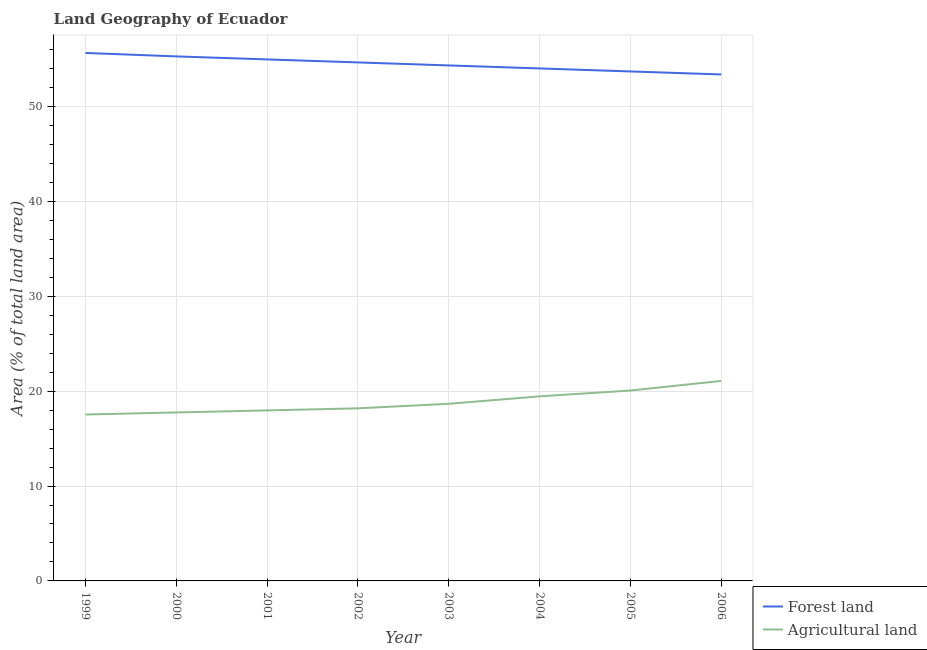Does the line corresponding to percentage of land area under forests intersect with the line corresponding to percentage of land area under agriculture?
Provide a short and direct response. No. Is the number of lines equal to the number of legend labels?
Provide a succinct answer. Yes. What is the percentage of land area under agriculture in 2004?
Ensure brevity in your answer.  19.45. Across all years, what is the maximum percentage of land area under forests?
Your answer should be very brief. 55.64. Across all years, what is the minimum percentage of land area under agriculture?
Provide a short and direct response. 17.54. What is the total percentage of land area under agriculture in the graph?
Provide a short and direct response. 150.71. What is the difference between the percentage of land area under forests in 2000 and that in 2005?
Offer a terse response. 1.59. What is the difference between the percentage of land area under forests in 1999 and the percentage of land area under agriculture in 2006?
Your response must be concise. 34.56. What is the average percentage of land area under forests per year?
Provide a succinct answer. 54.49. In the year 2001, what is the difference between the percentage of land area under agriculture and percentage of land area under forests?
Give a very brief answer. -36.99. In how many years, is the percentage of land area under agriculture greater than 22 %?
Ensure brevity in your answer.  0. What is the ratio of the percentage of land area under forests in 1999 to that in 2001?
Offer a terse response. 1.01. Is the percentage of land area under forests in 2004 less than that in 2006?
Make the answer very short. No. Is the difference between the percentage of land area under forests in 2000 and 2004 greater than the difference between the percentage of land area under agriculture in 2000 and 2004?
Make the answer very short. Yes. What is the difference between the highest and the second highest percentage of land area under agriculture?
Ensure brevity in your answer.  1.01. What is the difference between the highest and the lowest percentage of land area under forests?
Keep it short and to the point. 2.27. In how many years, is the percentage of land area under agriculture greater than the average percentage of land area under agriculture taken over all years?
Give a very brief answer. 3. Is the percentage of land area under forests strictly greater than the percentage of land area under agriculture over the years?
Offer a terse response. Yes. Is the percentage of land area under forests strictly less than the percentage of land area under agriculture over the years?
Provide a succinct answer. No. How many years are there in the graph?
Ensure brevity in your answer.  8. What is the difference between two consecutive major ticks on the Y-axis?
Offer a very short reply. 10. How many legend labels are there?
Make the answer very short. 2. What is the title of the graph?
Offer a very short reply. Land Geography of Ecuador. Does "By country of asylum" appear as one of the legend labels in the graph?
Offer a terse response. No. What is the label or title of the Y-axis?
Give a very brief answer. Area (% of total land area). What is the Area (% of total land area) of Forest land in 1999?
Your answer should be compact. 55.64. What is the Area (% of total land area) of Agricultural land in 1999?
Make the answer very short. 17.54. What is the Area (% of total land area) of Forest land in 2000?
Provide a succinct answer. 55.28. What is the Area (% of total land area) in Agricultural land in 2000?
Offer a very short reply. 17.75. What is the Area (% of total land area) in Forest land in 2001?
Ensure brevity in your answer.  54.96. What is the Area (% of total land area) of Agricultural land in 2001?
Offer a very short reply. 17.97. What is the Area (% of total land area) of Forest land in 2002?
Your answer should be compact. 54.64. What is the Area (% of total land area) of Agricultural land in 2002?
Your answer should be very brief. 18.19. What is the Area (% of total land area) in Forest land in 2003?
Offer a very short reply. 54.33. What is the Area (% of total land area) in Agricultural land in 2003?
Make the answer very short. 18.67. What is the Area (% of total land area) in Forest land in 2004?
Offer a terse response. 54.01. What is the Area (% of total land area) in Agricultural land in 2004?
Make the answer very short. 19.45. What is the Area (% of total land area) of Forest land in 2005?
Give a very brief answer. 53.69. What is the Area (% of total land area) of Agricultural land in 2005?
Ensure brevity in your answer.  20.07. What is the Area (% of total land area) of Forest land in 2006?
Give a very brief answer. 53.38. What is the Area (% of total land area) of Agricultural land in 2006?
Give a very brief answer. 21.08. Across all years, what is the maximum Area (% of total land area) of Forest land?
Your answer should be very brief. 55.64. Across all years, what is the maximum Area (% of total land area) in Agricultural land?
Provide a short and direct response. 21.08. Across all years, what is the minimum Area (% of total land area) of Forest land?
Provide a short and direct response. 53.38. Across all years, what is the minimum Area (% of total land area) in Agricultural land?
Offer a terse response. 17.54. What is the total Area (% of total land area) of Forest land in the graph?
Offer a terse response. 435.93. What is the total Area (% of total land area) in Agricultural land in the graph?
Your answer should be compact. 150.71. What is the difference between the Area (% of total land area) in Forest land in 1999 and that in 2000?
Your response must be concise. 0.36. What is the difference between the Area (% of total land area) in Agricultural land in 1999 and that in 2000?
Make the answer very short. -0.22. What is the difference between the Area (% of total land area) of Forest land in 1999 and that in 2001?
Make the answer very short. 0.68. What is the difference between the Area (% of total land area) in Agricultural land in 1999 and that in 2001?
Your answer should be compact. -0.43. What is the difference between the Area (% of total land area) in Agricultural land in 1999 and that in 2002?
Your answer should be very brief. -0.65. What is the difference between the Area (% of total land area) in Forest land in 1999 and that in 2003?
Provide a short and direct response. 1.31. What is the difference between the Area (% of total land area) in Agricultural land in 1999 and that in 2003?
Your answer should be compact. -1.13. What is the difference between the Area (% of total land area) of Forest land in 1999 and that in 2004?
Offer a very short reply. 1.63. What is the difference between the Area (% of total land area) in Agricultural land in 1999 and that in 2004?
Give a very brief answer. -1.91. What is the difference between the Area (% of total land area) in Forest land in 1999 and that in 2005?
Provide a short and direct response. 1.95. What is the difference between the Area (% of total land area) of Agricultural land in 1999 and that in 2005?
Offer a terse response. -2.53. What is the difference between the Area (% of total land area) in Forest land in 1999 and that in 2006?
Keep it short and to the point. 2.27. What is the difference between the Area (% of total land area) in Agricultural land in 1999 and that in 2006?
Ensure brevity in your answer.  -3.54. What is the difference between the Area (% of total land area) in Forest land in 2000 and that in 2001?
Provide a succinct answer. 0.32. What is the difference between the Area (% of total land area) of Agricultural land in 2000 and that in 2001?
Provide a short and direct response. -0.22. What is the difference between the Area (% of total land area) of Forest land in 2000 and that in 2002?
Provide a short and direct response. 0.63. What is the difference between the Area (% of total land area) of Agricultural land in 2000 and that in 2002?
Your answer should be very brief. -0.43. What is the difference between the Area (% of total land area) in Forest land in 2000 and that in 2003?
Provide a succinct answer. 0.95. What is the difference between the Area (% of total land area) of Agricultural land in 2000 and that in 2003?
Offer a terse response. -0.91. What is the difference between the Area (% of total land area) of Forest land in 2000 and that in 2004?
Give a very brief answer. 1.27. What is the difference between the Area (% of total land area) of Agricultural land in 2000 and that in 2004?
Your response must be concise. -1.7. What is the difference between the Area (% of total land area) in Forest land in 2000 and that in 2005?
Provide a succinct answer. 1.59. What is the difference between the Area (% of total land area) of Agricultural land in 2000 and that in 2005?
Your response must be concise. -2.31. What is the difference between the Area (% of total land area) in Forest land in 2000 and that in 2006?
Your response must be concise. 1.9. What is the difference between the Area (% of total land area) of Agricultural land in 2000 and that in 2006?
Offer a terse response. -3.32. What is the difference between the Area (% of total land area) in Forest land in 2001 and that in 2002?
Offer a terse response. 0.32. What is the difference between the Area (% of total land area) in Agricultural land in 2001 and that in 2002?
Provide a succinct answer. -0.22. What is the difference between the Area (% of total land area) in Forest land in 2001 and that in 2003?
Your response must be concise. 0.63. What is the difference between the Area (% of total land area) of Agricultural land in 2001 and that in 2003?
Provide a short and direct response. -0.7. What is the difference between the Area (% of total land area) of Forest land in 2001 and that in 2004?
Provide a succinct answer. 0.95. What is the difference between the Area (% of total land area) of Agricultural land in 2001 and that in 2004?
Ensure brevity in your answer.  -1.48. What is the difference between the Area (% of total land area) in Forest land in 2001 and that in 2005?
Ensure brevity in your answer.  1.27. What is the difference between the Area (% of total land area) of Agricultural land in 2001 and that in 2005?
Provide a short and direct response. -2.1. What is the difference between the Area (% of total land area) in Forest land in 2001 and that in 2006?
Offer a very short reply. 1.59. What is the difference between the Area (% of total land area) in Agricultural land in 2001 and that in 2006?
Your answer should be compact. -3.11. What is the difference between the Area (% of total land area) in Forest land in 2002 and that in 2003?
Make the answer very short. 0.32. What is the difference between the Area (% of total land area) of Agricultural land in 2002 and that in 2003?
Provide a short and direct response. -0.48. What is the difference between the Area (% of total land area) of Forest land in 2002 and that in 2004?
Provide a short and direct response. 0.63. What is the difference between the Area (% of total land area) in Agricultural land in 2002 and that in 2004?
Offer a very short reply. -1.26. What is the difference between the Area (% of total land area) in Forest land in 2002 and that in 2005?
Keep it short and to the point. 0.95. What is the difference between the Area (% of total land area) in Agricultural land in 2002 and that in 2005?
Make the answer very short. -1.88. What is the difference between the Area (% of total land area) in Forest land in 2002 and that in 2006?
Offer a very short reply. 1.27. What is the difference between the Area (% of total land area) of Agricultural land in 2002 and that in 2006?
Offer a very short reply. -2.89. What is the difference between the Area (% of total land area) in Forest land in 2003 and that in 2004?
Your answer should be very brief. 0.32. What is the difference between the Area (% of total land area) in Agricultural land in 2003 and that in 2004?
Ensure brevity in your answer.  -0.78. What is the difference between the Area (% of total land area) of Forest land in 2003 and that in 2005?
Make the answer very short. 0.63. What is the difference between the Area (% of total land area) of Agricultural land in 2003 and that in 2005?
Offer a very short reply. -1.4. What is the difference between the Area (% of total land area) in Forest land in 2003 and that in 2006?
Offer a very short reply. 0.95. What is the difference between the Area (% of total land area) in Agricultural land in 2003 and that in 2006?
Your response must be concise. -2.41. What is the difference between the Area (% of total land area) of Forest land in 2004 and that in 2005?
Keep it short and to the point. 0.32. What is the difference between the Area (% of total land area) in Agricultural land in 2004 and that in 2005?
Offer a terse response. -0.61. What is the difference between the Area (% of total land area) in Forest land in 2004 and that in 2006?
Keep it short and to the point. 0.63. What is the difference between the Area (% of total land area) in Agricultural land in 2004 and that in 2006?
Ensure brevity in your answer.  -1.63. What is the difference between the Area (% of total land area) of Forest land in 2005 and that in 2006?
Provide a succinct answer. 0.32. What is the difference between the Area (% of total land area) of Agricultural land in 2005 and that in 2006?
Provide a short and direct response. -1.01. What is the difference between the Area (% of total land area) in Forest land in 1999 and the Area (% of total land area) in Agricultural land in 2000?
Your response must be concise. 37.89. What is the difference between the Area (% of total land area) in Forest land in 1999 and the Area (% of total land area) in Agricultural land in 2001?
Ensure brevity in your answer.  37.67. What is the difference between the Area (% of total land area) in Forest land in 1999 and the Area (% of total land area) in Agricultural land in 2002?
Your answer should be very brief. 37.45. What is the difference between the Area (% of total land area) in Forest land in 1999 and the Area (% of total land area) in Agricultural land in 2003?
Your answer should be compact. 36.97. What is the difference between the Area (% of total land area) in Forest land in 1999 and the Area (% of total land area) in Agricultural land in 2004?
Provide a short and direct response. 36.19. What is the difference between the Area (% of total land area) of Forest land in 1999 and the Area (% of total land area) of Agricultural land in 2005?
Ensure brevity in your answer.  35.58. What is the difference between the Area (% of total land area) of Forest land in 1999 and the Area (% of total land area) of Agricultural land in 2006?
Offer a terse response. 34.56. What is the difference between the Area (% of total land area) in Forest land in 2000 and the Area (% of total land area) in Agricultural land in 2001?
Ensure brevity in your answer.  37.31. What is the difference between the Area (% of total land area) of Forest land in 2000 and the Area (% of total land area) of Agricultural land in 2002?
Ensure brevity in your answer.  37.09. What is the difference between the Area (% of total land area) in Forest land in 2000 and the Area (% of total land area) in Agricultural land in 2003?
Your answer should be very brief. 36.61. What is the difference between the Area (% of total land area) of Forest land in 2000 and the Area (% of total land area) of Agricultural land in 2004?
Make the answer very short. 35.83. What is the difference between the Area (% of total land area) of Forest land in 2000 and the Area (% of total land area) of Agricultural land in 2005?
Offer a very short reply. 35.21. What is the difference between the Area (% of total land area) in Forest land in 2000 and the Area (% of total land area) in Agricultural land in 2006?
Your response must be concise. 34.2. What is the difference between the Area (% of total land area) in Forest land in 2001 and the Area (% of total land area) in Agricultural land in 2002?
Provide a short and direct response. 36.77. What is the difference between the Area (% of total land area) of Forest land in 2001 and the Area (% of total land area) of Agricultural land in 2003?
Keep it short and to the point. 36.29. What is the difference between the Area (% of total land area) of Forest land in 2001 and the Area (% of total land area) of Agricultural land in 2004?
Provide a succinct answer. 35.51. What is the difference between the Area (% of total land area) in Forest land in 2001 and the Area (% of total land area) in Agricultural land in 2005?
Offer a very short reply. 34.9. What is the difference between the Area (% of total land area) in Forest land in 2001 and the Area (% of total land area) in Agricultural land in 2006?
Make the answer very short. 33.88. What is the difference between the Area (% of total land area) in Forest land in 2002 and the Area (% of total land area) in Agricultural land in 2003?
Keep it short and to the point. 35.98. What is the difference between the Area (% of total land area) in Forest land in 2002 and the Area (% of total land area) in Agricultural land in 2004?
Give a very brief answer. 35.19. What is the difference between the Area (% of total land area) of Forest land in 2002 and the Area (% of total land area) of Agricultural land in 2005?
Offer a very short reply. 34.58. What is the difference between the Area (% of total land area) in Forest land in 2002 and the Area (% of total land area) in Agricultural land in 2006?
Your response must be concise. 33.57. What is the difference between the Area (% of total land area) of Forest land in 2003 and the Area (% of total land area) of Agricultural land in 2004?
Give a very brief answer. 34.88. What is the difference between the Area (% of total land area) in Forest land in 2003 and the Area (% of total land area) in Agricultural land in 2005?
Give a very brief answer. 34.26. What is the difference between the Area (% of total land area) of Forest land in 2003 and the Area (% of total land area) of Agricultural land in 2006?
Your response must be concise. 33.25. What is the difference between the Area (% of total land area) in Forest land in 2004 and the Area (% of total land area) in Agricultural land in 2005?
Your answer should be compact. 33.94. What is the difference between the Area (% of total land area) in Forest land in 2004 and the Area (% of total land area) in Agricultural land in 2006?
Offer a very short reply. 32.93. What is the difference between the Area (% of total land area) in Forest land in 2005 and the Area (% of total land area) in Agricultural land in 2006?
Provide a short and direct response. 32.62. What is the average Area (% of total land area) in Forest land per year?
Give a very brief answer. 54.49. What is the average Area (% of total land area) of Agricultural land per year?
Ensure brevity in your answer.  18.84. In the year 1999, what is the difference between the Area (% of total land area) of Forest land and Area (% of total land area) of Agricultural land?
Offer a very short reply. 38.1. In the year 2000, what is the difference between the Area (% of total land area) in Forest land and Area (% of total land area) in Agricultural land?
Make the answer very short. 37.52. In the year 2001, what is the difference between the Area (% of total land area) in Forest land and Area (% of total land area) in Agricultural land?
Offer a terse response. 36.99. In the year 2002, what is the difference between the Area (% of total land area) in Forest land and Area (% of total land area) in Agricultural land?
Offer a very short reply. 36.46. In the year 2003, what is the difference between the Area (% of total land area) of Forest land and Area (% of total land area) of Agricultural land?
Give a very brief answer. 35.66. In the year 2004, what is the difference between the Area (% of total land area) of Forest land and Area (% of total land area) of Agricultural land?
Your answer should be very brief. 34.56. In the year 2005, what is the difference between the Area (% of total land area) of Forest land and Area (% of total land area) of Agricultural land?
Give a very brief answer. 33.63. In the year 2006, what is the difference between the Area (% of total land area) in Forest land and Area (% of total land area) in Agricultural land?
Offer a terse response. 32.3. What is the ratio of the Area (% of total land area) of Forest land in 1999 to that in 2000?
Make the answer very short. 1.01. What is the ratio of the Area (% of total land area) of Agricultural land in 1999 to that in 2000?
Give a very brief answer. 0.99. What is the ratio of the Area (% of total land area) of Forest land in 1999 to that in 2001?
Offer a very short reply. 1.01. What is the ratio of the Area (% of total land area) in Agricultural land in 1999 to that in 2001?
Your answer should be compact. 0.98. What is the ratio of the Area (% of total land area) in Forest land in 1999 to that in 2002?
Make the answer very short. 1.02. What is the ratio of the Area (% of total land area) in Forest land in 1999 to that in 2003?
Make the answer very short. 1.02. What is the ratio of the Area (% of total land area) of Agricultural land in 1999 to that in 2003?
Keep it short and to the point. 0.94. What is the ratio of the Area (% of total land area) of Forest land in 1999 to that in 2004?
Offer a terse response. 1.03. What is the ratio of the Area (% of total land area) in Agricultural land in 1999 to that in 2004?
Your answer should be very brief. 0.9. What is the ratio of the Area (% of total land area) of Forest land in 1999 to that in 2005?
Ensure brevity in your answer.  1.04. What is the ratio of the Area (% of total land area) of Agricultural land in 1999 to that in 2005?
Ensure brevity in your answer.  0.87. What is the ratio of the Area (% of total land area) in Forest land in 1999 to that in 2006?
Make the answer very short. 1.04. What is the ratio of the Area (% of total land area) of Agricultural land in 1999 to that in 2006?
Provide a short and direct response. 0.83. What is the ratio of the Area (% of total land area) of Forest land in 2000 to that in 2001?
Your response must be concise. 1.01. What is the ratio of the Area (% of total land area) in Agricultural land in 2000 to that in 2001?
Ensure brevity in your answer.  0.99. What is the ratio of the Area (% of total land area) of Forest land in 2000 to that in 2002?
Offer a very short reply. 1.01. What is the ratio of the Area (% of total land area) of Agricultural land in 2000 to that in 2002?
Offer a very short reply. 0.98. What is the ratio of the Area (% of total land area) of Forest land in 2000 to that in 2003?
Your answer should be compact. 1.02. What is the ratio of the Area (% of total land area) of Agricultural land in 2000 to that in 2003?
Ensure brevity in your answer.  0.95. What is the ratio of the Area (% of total land area) of Forest land in 2000 to that in 2004?
Provide a short and direct response. 1.02. What is the ratio of the Area (% of total land area) of Agricultural land in 2000 to that in 2004?
Give a very brief answer. 0.91. What is the ratio of the Area (% of total land area) in Forest land in 2000 to that in 2005?
Give a very brief answer. 1.03. What is the ratio of the Area (% of total land area) in Agricultural land in 2000 to that in 2005?
Keep it short and to the point. 0.88. What is the ratio of the Area (% of total land area) of Forest land in 2000 to that in 2006?
Your answer should be compact. 1.04. What is the ratio of the Area (% of total land area) of Agricultural land in 2000 to that in 2006?
Your answer should be compact. 0.84. What is the ratio of the Area (% of total land area) of Forest land in 2001 to that in 2002?
Provide a succinct answer. 1.01. What is the ratio of the Area (% of total land area) in Forest land in 2001 to that in 2003?
Your response must be concise. 1.01. What is the ratio of the Area (% of total land area) in Agricultural land in 2001 to that in 2003?
Your answer should be very brief. 0.96. What is the ratio of the Area (% of total land area) of Forest land in 2001 to that in 2004?
Offer a terse response. 1.02. What is the ratio of the Area (% of total land area) of Agricultural land in 2001 to that in 2004?
Your response must be concise. 0.92. What is the ratio of the Area (% of total land area) of Forest land in 2001 to that in 2005?
Give a very brief answer. 1.02. What is the ratio of the Area (% of total land area) in Agricultural land in 2001 to that in 2005?
Your response must be concise. 0.9. What is the ratio of the Area (% of total land area) of Forest land in 2001 to that in 2006?
Ensure brevity in your answer.  1.03. What is the ratio of the Area (% of total land area) in Agricultural land in 2001 to that in 2006?
Ensure brevity in your answer.  0.85. What is the ratio of the Area (% of total land area) of Agricultural land in 2002 to that in 2003?
Keep it short and to the point. 0.97. What is the ratio of the Area (% of total land area) of Forest land in 2002 to that in 2004?
Make the answer very short. 1.01. What is the ratio of the Area (% of total land area) of Agricultural land in 2002 to that in 2004?
Offer a terse response. 0.94. What is the ratio of the Area (% of total land area) in Forest land in 2002 to that in 2005?
Your answer should be very brief. 1.02. What is the ratio of the Area (% of total land area) in Agricultural land in 2002 to that in 2005?
Your response must be concise. 0.91. What is the ratio of the Area (% of total land area) in Forest land in 2002 to that in 2006?
Provide a succinct answer. 1.02. What is the ratio of the Area (% of total land area) of Agricultural land in 2002 to that in 2006?
Your answer should be very brief. 0.86. What is the ratio of the Area (% of total land area) of Forest land in 2003 to that in 2004?
Your answer should be compact. 1.01. What is the ratio of the Area (% of total land area) of Agricultural land in 2003 to that in 2004?
Make the answer very short. 0.96. What is the ratio of the Area (% of total land area) in Forest land in 2003 to that in 2005?
Your answer should be compact. 1.01. What is the ratio of the Area (% of total land area) of Agricultural land in 2003 to that in 2005?
Provide a short and direct response. 0.93. What is the ratio of the Area (% of total land area) of Forest land in 2003 to that in 2006?
Offer a very short reply. 1.02. What is the ratio of the Area (% of total land area) of Agricultural land in 2003 to that in 2006?
Provide a succinct answer. 0.89. What is the ratio of the Area (% of total land area) in Forest land in 2004 to that in 2005?
Your answer should be compact. 1.01. What is the ratio of the Area (% of total land area) of Agricultural land in 2004 to that in 2005?
Provide a succinct answer. 0.97. What is the ratio of the Area (% of total land area) in Forest land in 2004 to that in 2006?
Your answer should be compact. 1.01. What is the ratio of the Area (% of total land area) of Agricultural land in 2004 to that in 2006?
Offer a terse response. 0.92. What is the ratio of the Area (% of total land area) of Forest land in 2005 to that in 2006?
Provide a short and direct response. 1.01. What is the difference between the highest and the second highest Area (% of total land area) in Forest land?
Your answer should be compact. 0.36. What is the difference between the highest and the second highest Area (% of total land area) in Agricultural land?
Your response must be concise. 1.01. What is the difference between the highest and the lowest Area (% of total land area) in Forest land?
Keep it short and to the point. 2.27. What is the difference between the highest and the lowest Area (% of total land area) of Agricultural land?
Ensure brevity in your answer.  3.54. 